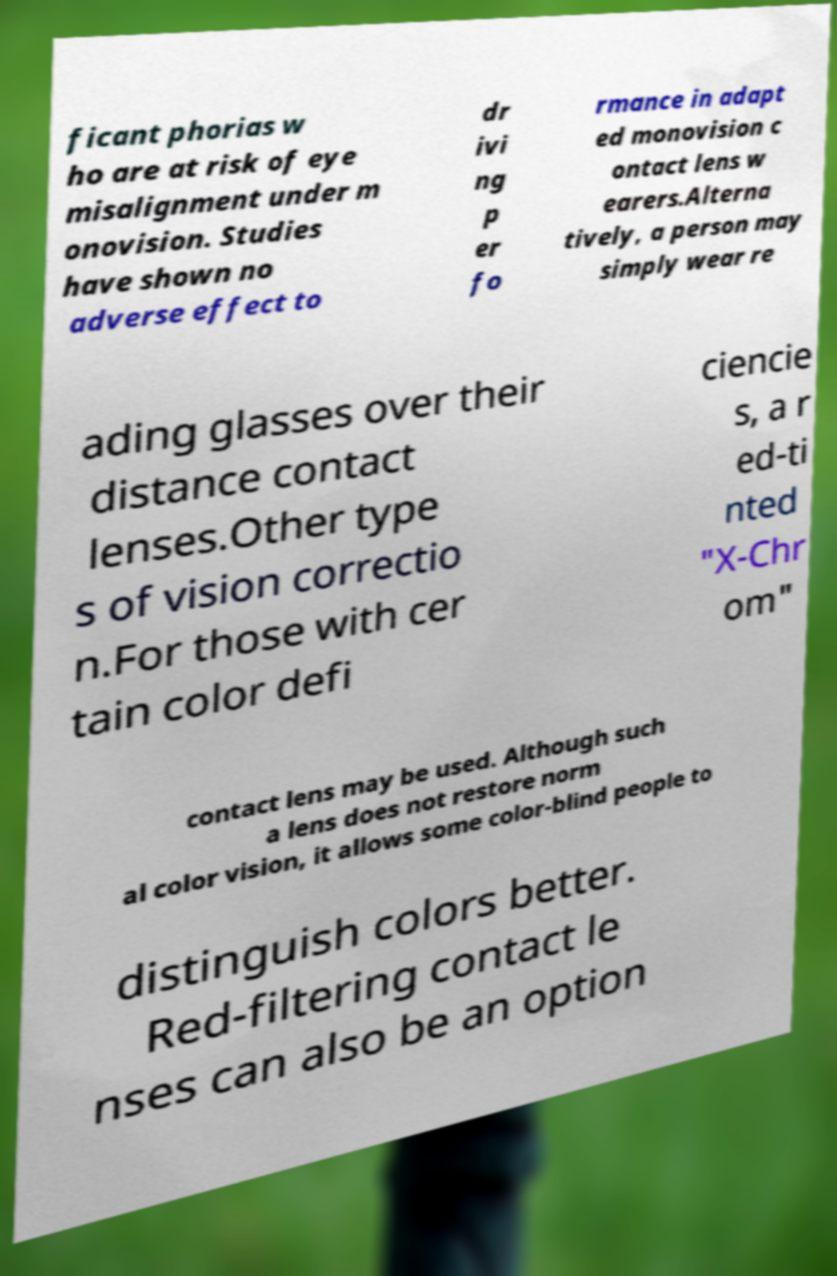Please read and relay the text visible in this image. What does it say? ficant phorias w ho are at risk of eye misalignment under m onovision. Studies have shown no adverse effect to dr ivi ng p er fo rmance in adapt ed monovision c ontact lens w earers.Alterna tively, a person may simply wear re ading glasses over their distance contact lenses.Other type s of vision correctio n.For those with cer tain color defi ciencie s, a r ed-ti nted "X-Chr om" contact lens may be used. Although such a lens does not restore norm al color vision, it allows some color-blind people to distinguish colors better. Red-filtering contact le nses can also be an option 